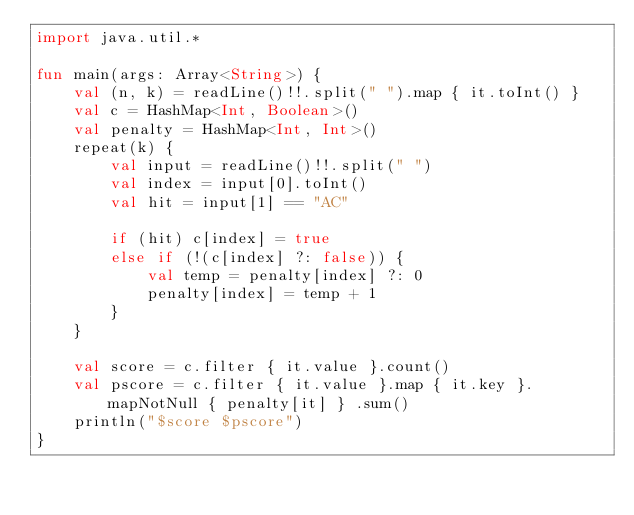Convert code to text. <code><loc_0><loc_0><loc_500><loc_500><_Kotlin_>import java.util.*

fun main(args: Array<String>) {
    val (n, k) = readLine()!!.split(" ").map { it.toInt() }
    val c = HashMap<Int, Boolean>()
    val penalty = HashMap<Int, Int>()
    repeat(k) {
        val input = readLine()!!.split(" ")
        val index = input[0].toInt()
        val hit = input[1] == "AC"

        if (hit) c[index] = true
        else if (!(c[index] ?: false)) {
            val temp = penalty[index] ?: 0
            penalty[index] = temp + 1
        }
    }

    val score = c.filter { it.value }.count()
    val pscore = c.filter { it.value }.map { it.key }.mapNotNull { penalty[it] } .sum()
    println("$score $pscore")
}
</code> 